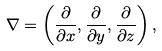Convert formula to latex. <formula><loc_0><loc_0><loc_500><loc_500>\nabla = \left ( { \frac { \partial } { \partial x } } , { \frac { \partial } { \partial y } } , { \frac { \partial } { \partial z } } \right ) ,</formula> 